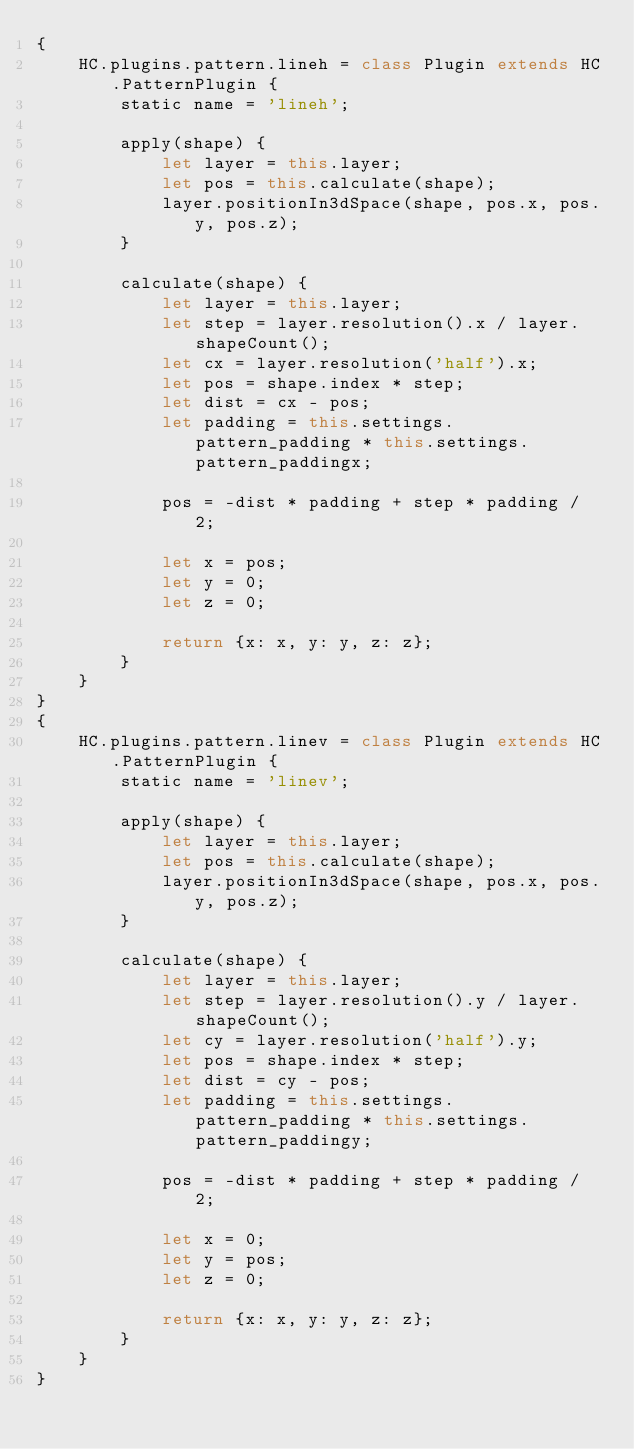Convert code to text. <code><loc_0><loc_0><loc_500><loc_500><_JavaScript_>{
    HC.plugins.pattern.lineh = class Plugin extends HC.PatternPlugin {
        static name = 'lineh';

        apply(shape) {
            let layer = this.layer;
            let pos = this.calculate(shape);
            layer.positionIn3dSpace(shape, pos.x, pos.y, pos.z);
        }

        calculate(shape) {
            let layer = this.layer;
            let step = layer.resolution().x / layer.shapeCount();
            let cx = layer.resolution('half').x;
            let pos = shape.index * step;
            let dist = cx - pos;
            let padding = this.settings.pattern_padding * this.settings.pattern_paddingx;

            pos = -dist * padding + step * padding / 2;

            let x = pos;
            let y = 0;
            let z = 0;

            return {x: x, y: y, z: z};
        }
    }
}
{
    HC.plugins.pattern.linev = class Plugin extends HC.PatternPlugin {
        static name = 'linev';

        apply(shape) {
            let layer = this.layer;
            let pos = this.calculate(shape);
            layer.positionIn3dSpace(shape, pos.x, pos.y, pos.z);
        }

        calculate(shape) {
            let layer = this.layer;
            let step = layer.resolution().y / layer.shapeCount();
            let cy = layer.resolution('half').y;
            let pos = shape.index * step;
            let dist = cy - pos;
            let padding = this.settings.pattern_padding * this.settings.pattern_paddingy;

            pos = -dist * padding + step * padding / 2;

            let x = 0;
            let y = pos;
            let z = 0;

            return {x: x, y: y, z: z};
        }
    }
}
</code> 